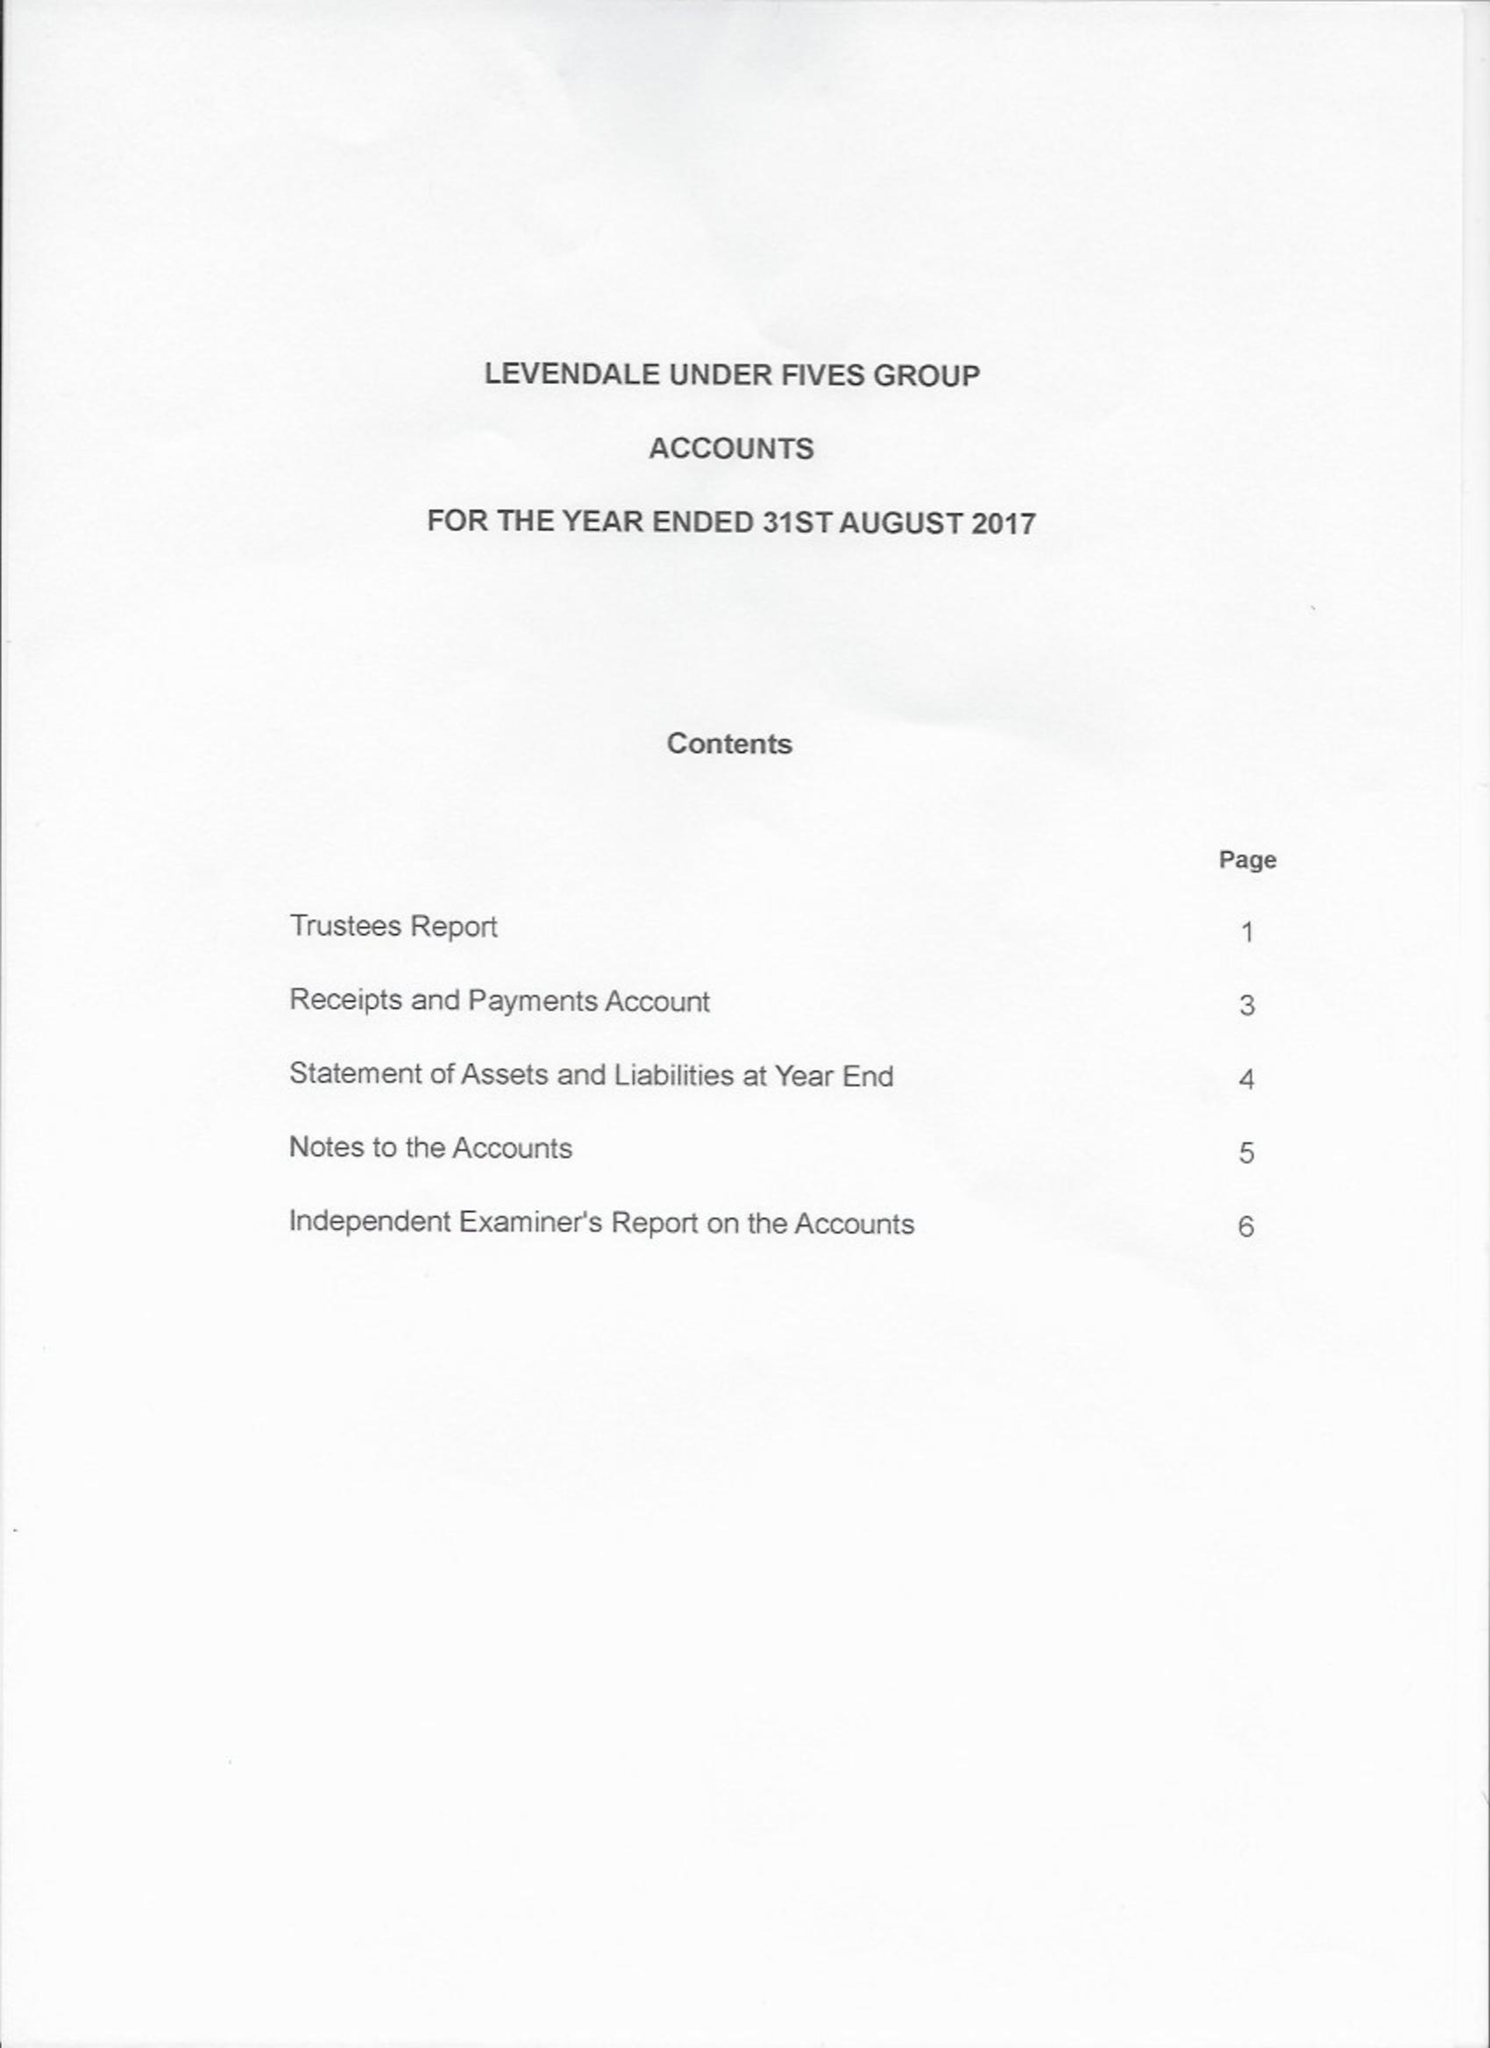What is the value for the charity_name?
Answer the question using a single word or phrase. Levendale Under Fives Group 